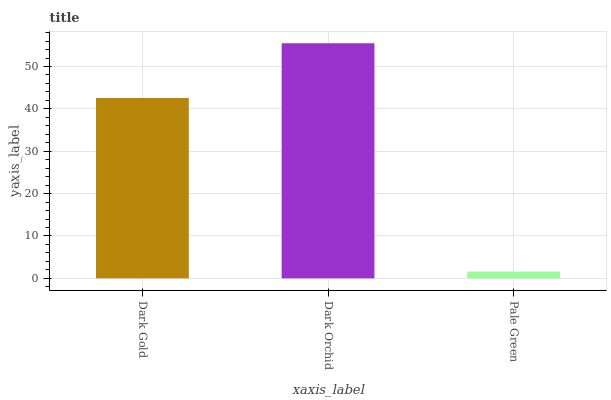Is Pale Green the minimum?
Answer yes or no. Yes. Is Dark Orchid the maximum?
Answer yes or no. Yes. Is Dark Orchid the minimum?
Answer yes or no. No. Is Pale Green the maximum?
Answer yes or no. No. Is Dark Orchid greater than Pale Green?
Answer yes or no. Yes. Is Pale Green less than Dark Orchid?
Answer yes or no. Yes. Is Pale Green greater than Dark Orchid?
Answer yes or no. No. Is Dark Orchid less than Pale Green?
Answer yes or no. No. Is Dark Gold the high median?
Answer yes or no. Yes. Is Dark Gold the low median?
Answer yes or no. Yes. Is Dark Orchid the high median?
Answer yes or no. No. Is Pale Green the low median?
Answer yes or no. No. 